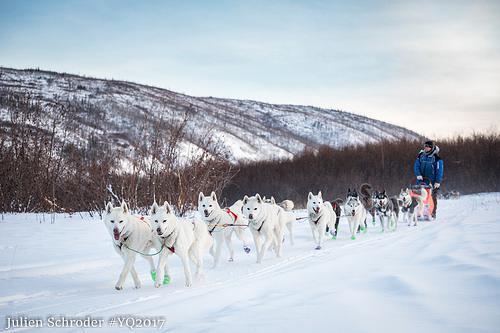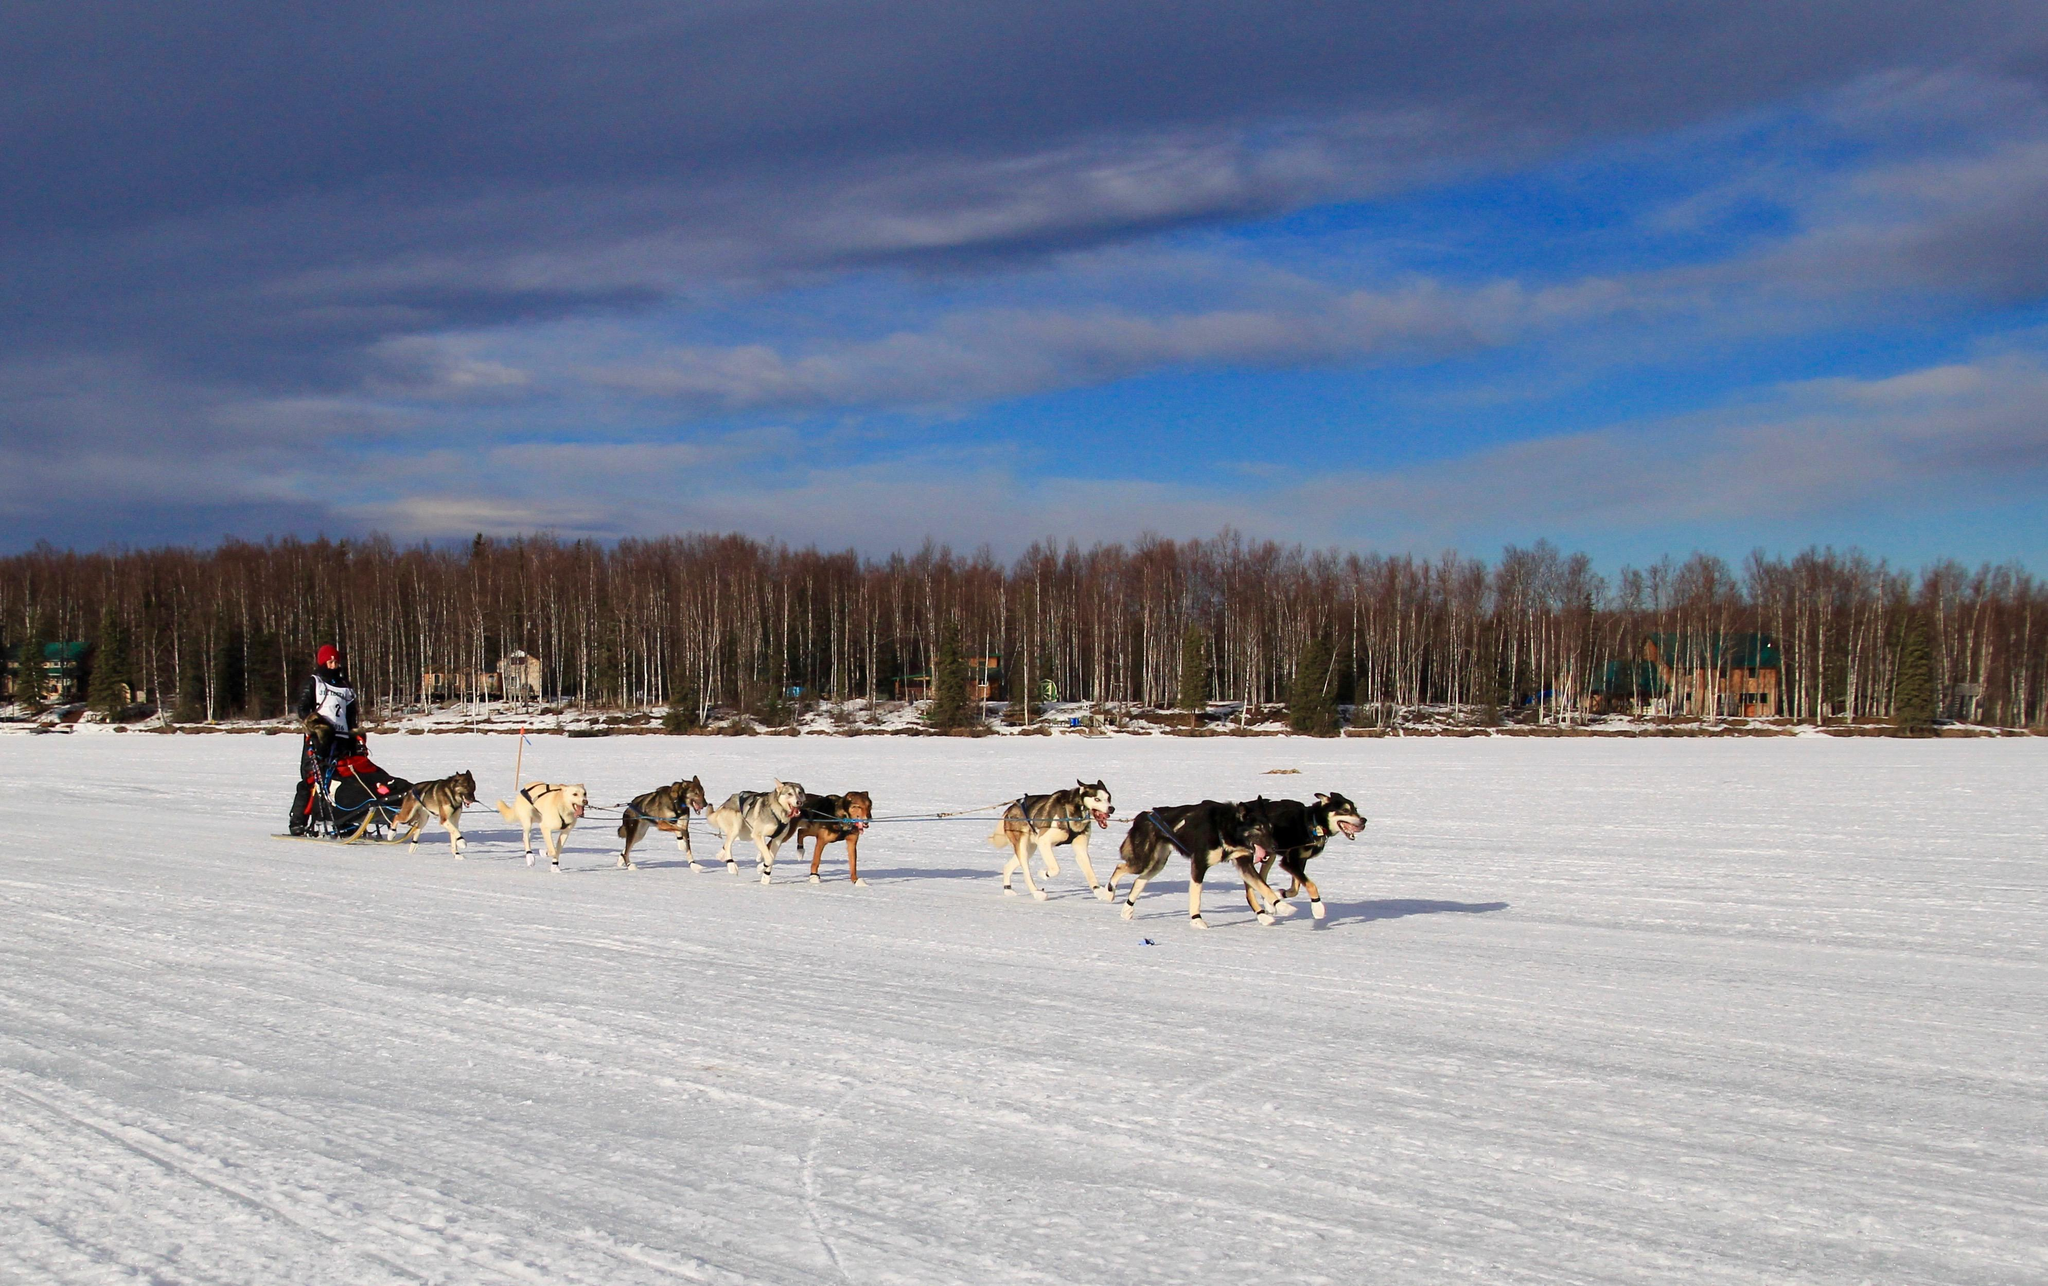The first image is the image on the left, the second image is the image on the right. Analyze the images presented: Is the assertion "Tall trees but no tall hills line the horizon in both images of sled dogs moving across the snow, and at least one image shows the sun shining above the trees." valid? Answer yes or no. No. 